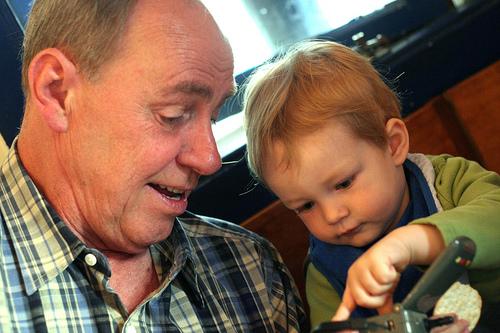Are these two brothers?
Short answer required. No. What is the boy pointing at?
Quick response, please. Phone. What color is child's sweater?
Quick response, please. Green. What color is the kids hair?
Be succinct. Blonde. 